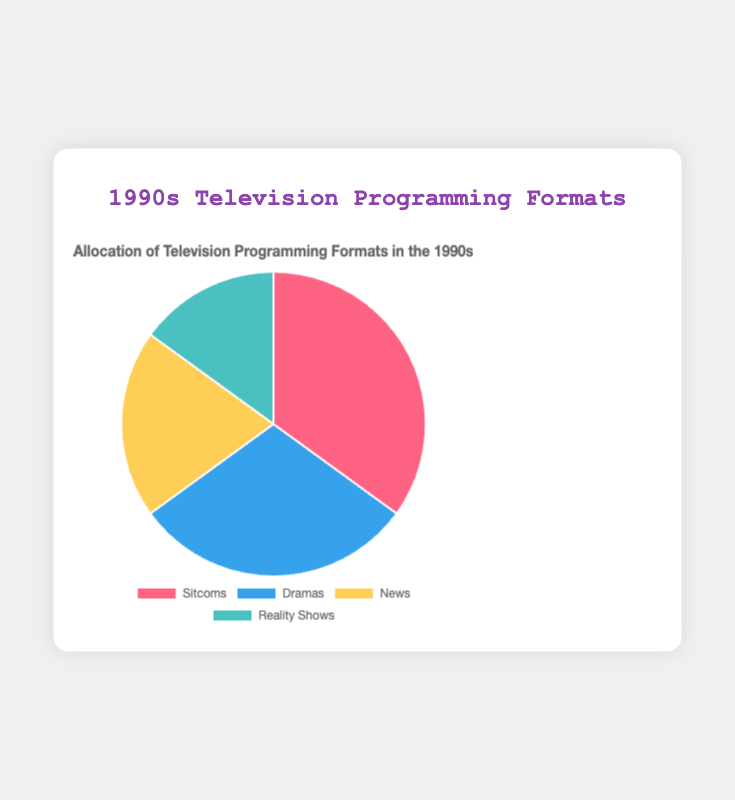Which format has the largest percentage allocation in the 1990s? Based on the pie chart, sitcoms have the largest percentage allocation at 35%.
Answer: Sitcoms Which format has the smallest percentage allocation in the 1990s? Based on the pie chart, reality shows have the smallest percentage allocation at 15%.
Answer: Reality Shows What is the combined percentage allocation of sitcoms and dramas? The pie chart shows sitcoms have 35% and dramas have 30%. Adding these together, 35% + 30% = 65%.
Answer: 65% How much more is the percentage allocation of sitcoms compared to reality shows? The percentage allocation for sitcoms is 35%, and for reality shows, it’s 15%. Subtracting these, 35% - 15% = 20%.
Answer: 20% Which formats together have an allocation greater than 50%? Sitcoms (35%) and dramas (30%) together have an allocation of 65%, which is greater than 50%.
Answer: Sitcoms and Dramas Compare the combined allocation of news and reality shows with sitcoms. Which is greater? The combined allocation of news (20%) and reality shows (15%) is 35%, which is equal to the allocation of sitcoms (35%).
Answer: Equal Which format is represented by the yellow segment in the pie chart? By looking at the pie chart, the yellow segment represents news.
Answer: News What is the sum of the percentage allocations of news and dramas? According to the pie chart, news has a 20% allocation and dramas have a 30% allocation. Adding these together, 20% + 30% = 50%.
Answer: 50% If we group reality shows and news, which format has a higher allocation: sitcoms or the group of reality shows and news? Sitcoms have a 35% allocation, while the combined allocation of reality shows (15%) and news (20%) is 35%. Both have equal allocations.
Answer: Equal Which format is represented by the segment with a light blue color in the pie chart? By observing the colors in the pie chart, the light blue segment represents reality shows.
Answer: Reality Shows 